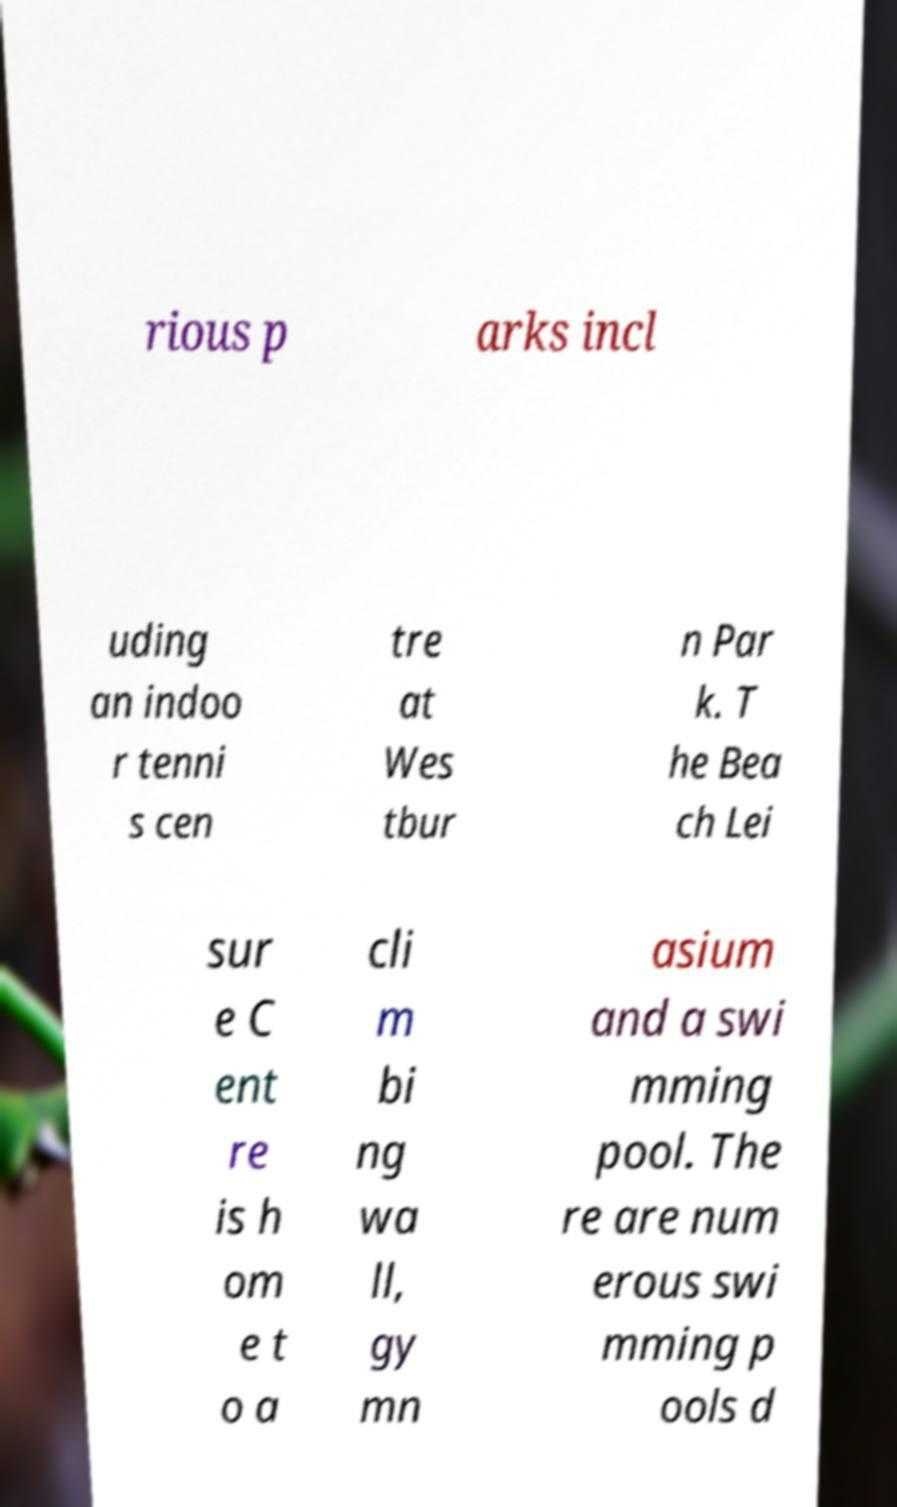Please read and relay the text visible in this image. What does it say? rious p arks incl uding an indoo r tenni s cen tre at Wes tbur n Par k. T he Bea ch Lei sur e C ent re is h om e t o a cli m bi ng wa ll, gy mn asium and a swi mming pool. The re are num erous swi mming p ools d 